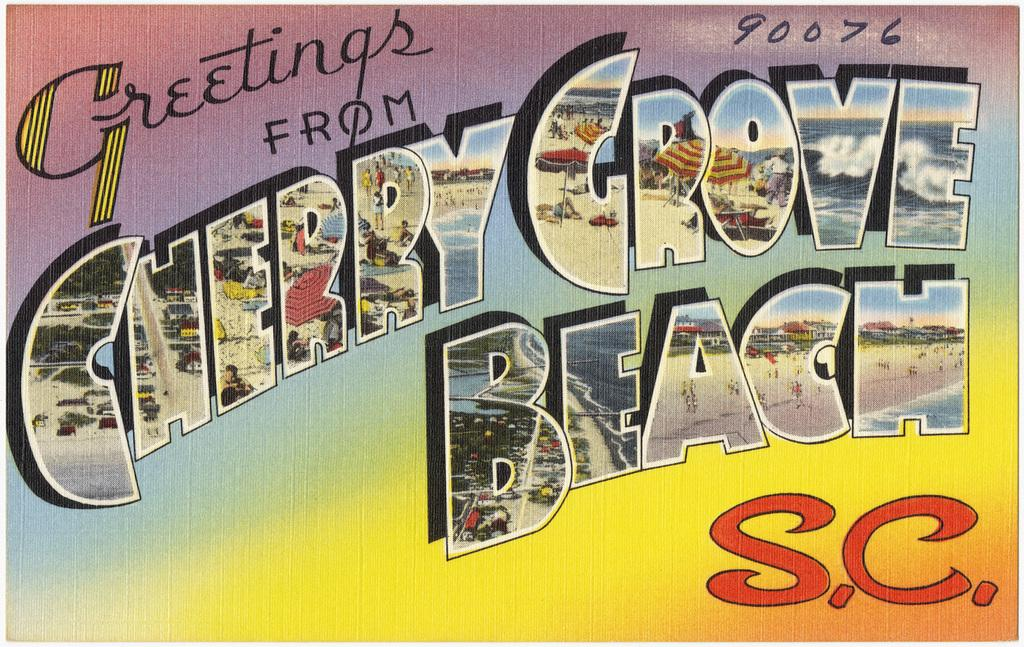<image>
Share a concise interpretation of the image provided. A greeting post card from Cherry Grove Beach. 